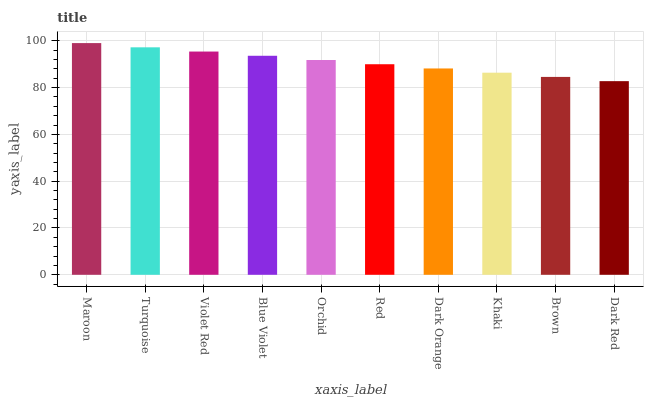Is Dark Red the minimum?
Answer yes or no. Yes. Is Maroon the maximum?
Answer yes or no. Yes. Is Turquoise the minimum?
Answer yes or no. No. Is Turquoise the maximum?
Answer yes or no. No. Is Maroon greater than Turquoise?
Answer yes or no. Yes. Is Turquoise less than Maroon?
Answer yes or no. Yes. Is Turquoise greater than Maroon?
Answer yes or no. No. Is Maroon less than Turquoise?
Answer yes or no. No. Is Orchid the high median?
Answer yes or no. Yes. Is Red the low median?
Answer yes or no. Yes. Is Dark Orange the high median?
Answer yes or no. No. Is Blue Violet the low median?
Answer yes or no. No. 